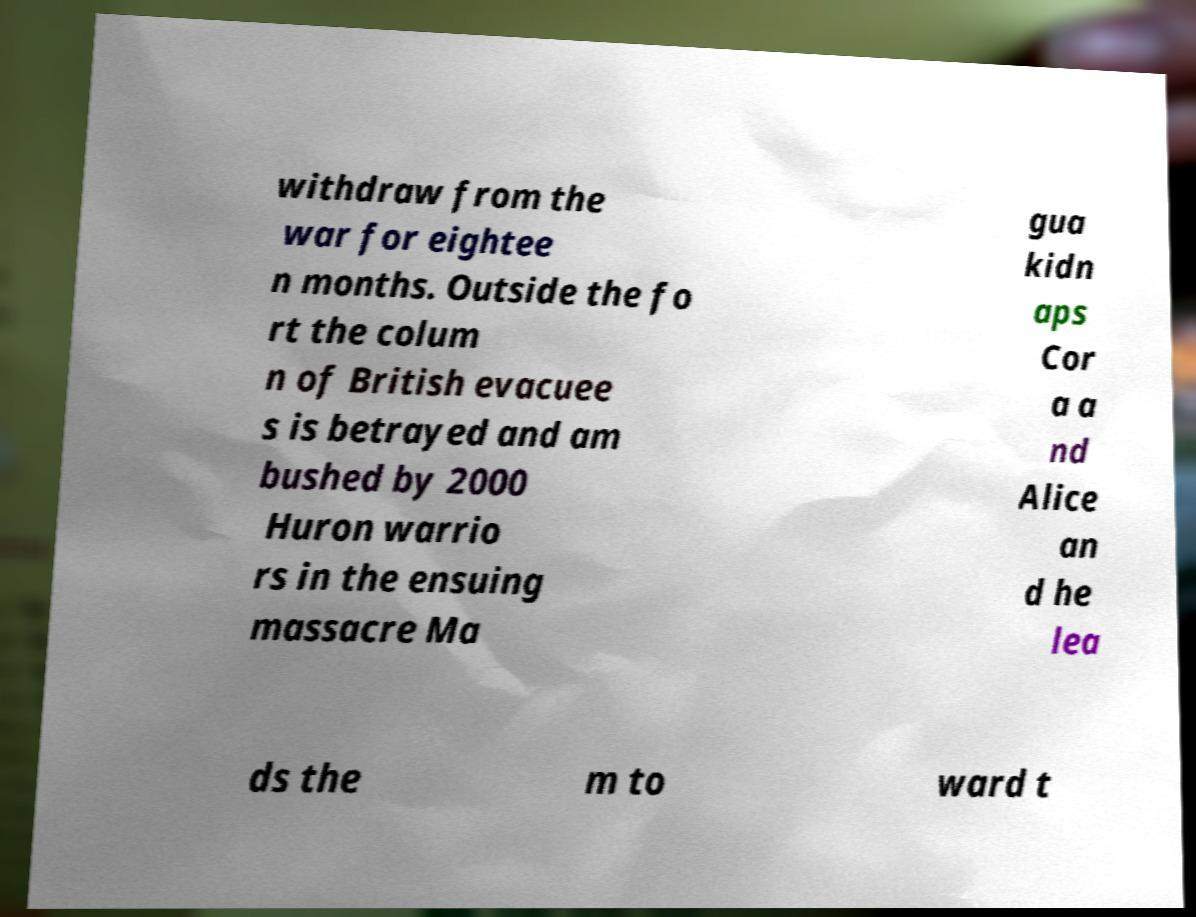For documentation purposes, I need the text within this image transcribed. Could you provide that? withdraw from the war for eightee n months. Outside the fo rt the colum n of British evacuee s is betrayed and am bushed by 2000 Huron warrio rs in the ensuing massacre Ma gua kidn aps Cor a a nd Alice an d he lea ds the m to ward t 